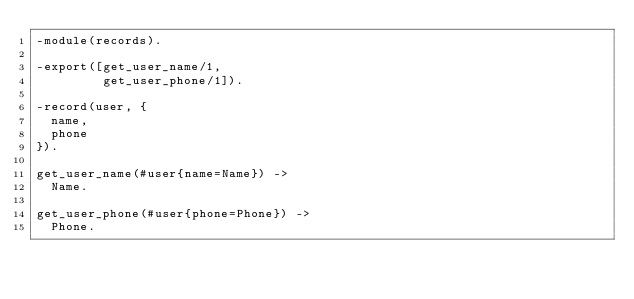<code> <loc_0><loc_0><loc_500><loc_500><_Erlang_>-module(records).

-export([get_user_name/1,
         get_user_phone/1]).

-record(user, {
  name,
  phone
}).

get_user_name(#user{name=Name}) ->
  Name.

get_user_phone(#user{phone=Phone}) ->
  Phone.

</code> 